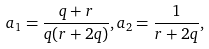<formula> <loc_0><loc_0><loc_500><loc_500>a _ { 1 } = \frac { q + r } { q ( r + 2 q ) } , a _ { 2 } = \frac { 1 } { r + 2 q } ,</formula> 